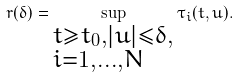<formula> <loc_0><loc_0><loc_500><loc_500>r ( \delta ) = \sup _ { \begin{subarray} { c } t \geqslant t _ { 0 } , | u | \leqslant \delta , \\ i = 1 , \dots , N \end{subarray} } \tau _ { i } ( t , u ) .</formula> 